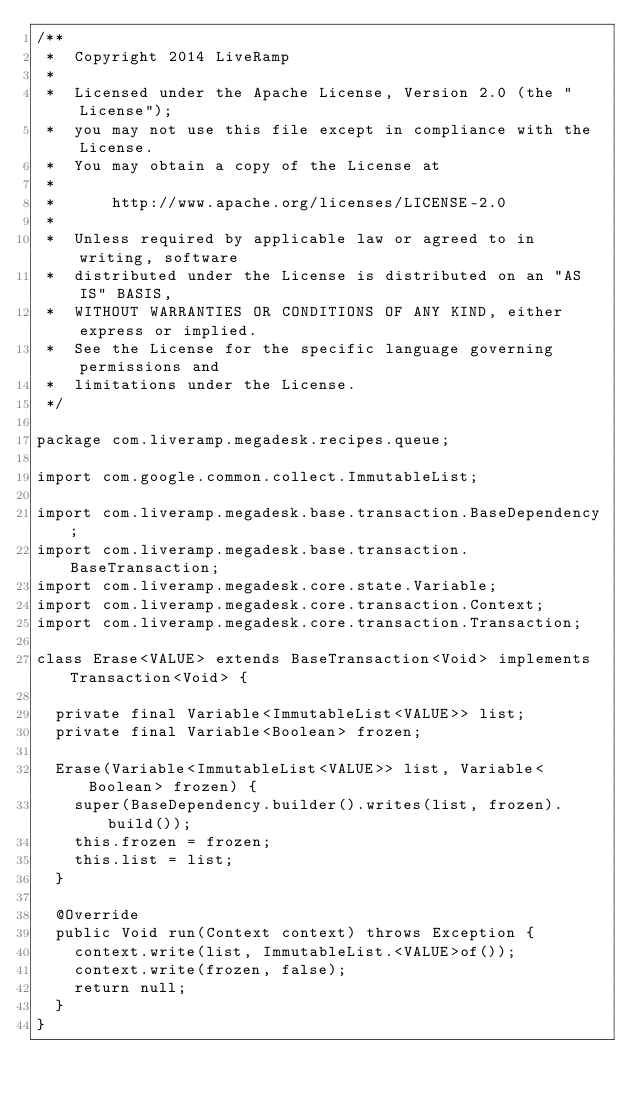Convert code to text. <code><loc_0><loc_0><loc_500><loc_500><_Java_>/**
 *  Copyright 2014 LiveRamp
 *
 *  Licensed under the Apache License, Version 2.0 (the "License");
 *  you may not use this file except in compliance with the License.
 *  You may obtain a copy of the License at
 *
 *      http://www.apache.org/licenses/LICENSE-2.0
 *
 *  Unless required by applicable law or agreed to in writing, software
 *  distributed under the License is distributed on an "AS IS" BASIS,
 *  WITHOUT WARRANTIES OR CONDITIONS OF ANY KIND, either express or implied.
 *  See the License for the specific language governing permissions and
 *  limitations under the License.
 */

package com.liveramp.megadesk.recipes.queue;

import com.google.common.collect.ImmutableList;

import com.liveramp.megadesk.base.transaction.BaseDependency;
import com.liveramp.megadesk.base.transaction.BaseTransaction;
import com.liveramp.megadesk.core.state.Variable;
import com.liveramp.megadesk.core.transaction.Context;
import com.liveramp.megadesk.core.transaction.Transaction;

class Erase<VALUE> extends BaseTransaction<Void> implements Transaction<Void> {

  private final Variable<ImmutableList<VALUE>> list;
  private final Variable<Boolean> frozen;

  Erase(Variable<ImmutableList<VALUE>> list, Variable<Boolean> frozen) {
    super(BaseDependency.builder().writes(list, frozen).build());
    this.frozen = frozen;
    this.list = list;
  }

  @Override
  public Void run(Context context) throws Exception {
    context.write(list, ImmutableList.<VALUE>of());
    context.write(frozen, false);
    return null;
  }
}
</code> 